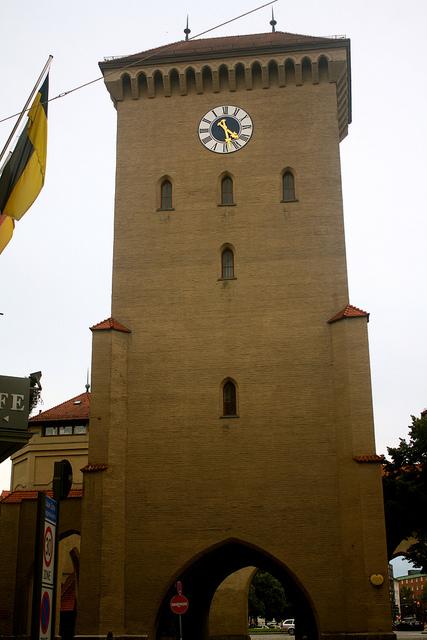What time does the clock say?
Answer briefly. 4:30. Is the camera pointing up or down?
Short answer required. Up. Is this a church?
Quick response, please. No. What time is it?
Give a very brief answer. 4:30. What colors are on the flag?
Short answer required. Yellow and blue. 